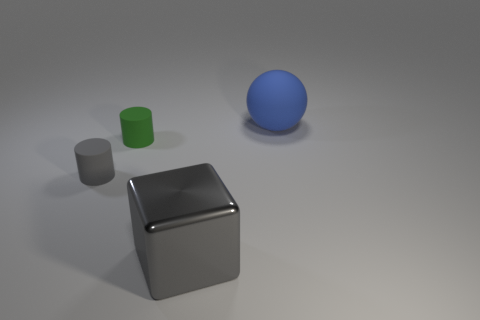Are there any other things that have the same shape as the large gray metallic thing?
Your response must be concise. No. There is a large object in front of the rubber cylinder that is behind the gray object behind the big gray metal thing; what is it made of?
Provide a succinct answer. Metal. Is there anything else that is made of the same material as the big gray thing?
Provide a succinct answer. No. There is a green cylinder; is its size the same as the thing left of the small green cylinder?
Provide a succinct answer. Yes. What number of things are either tiny green matte things in front of the blue rubber sphere or big things left of the blue rubber ball?
Offer a very short reply. 2. There is a object right of the large gray cube; what color is it?
Provide a short and direct response. Blue. Are there any matte cylinders that are in front of the large thing to the right of the gray metallic cube?
Make the answer very short. Yes. Is the number of rubber spheres less than the number of tiny rubber objects?
Give a very brief answer. Yes. What material is the cylinder that is right of the small thing that is in front of the tiny green matte object made of?
Offer a very short reply. Rubber. Is the size of the blue matte ball the same as the cube?
Your response must be concise. Yes. 